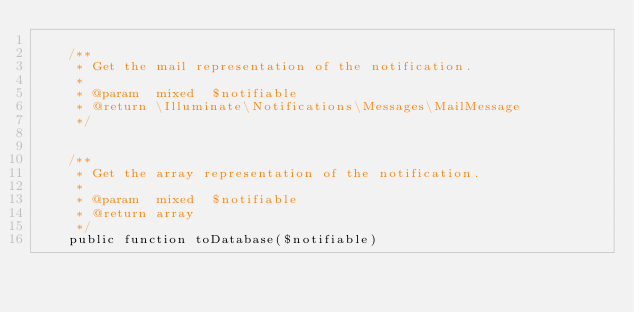Convert code to text. <code><loc_0><loc_0><loc_500><loc_500><_PHP_>
    /**
     * Get the mail representation of the notification.
     *
     * @param  mixed  $notifiable
     * @return \Illuminate\Notifications\Messages\MailMessage
     */


    /**
     * Get the array representation of the notification.
     *
     * @param  mixed  $notifiable
     * @return array
     */
    public function toDatabase($notifiable)</code> 